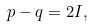<formula> <loc_0><loc_0><loc_500><loc_500>p - q = 2 I ,</formula> 